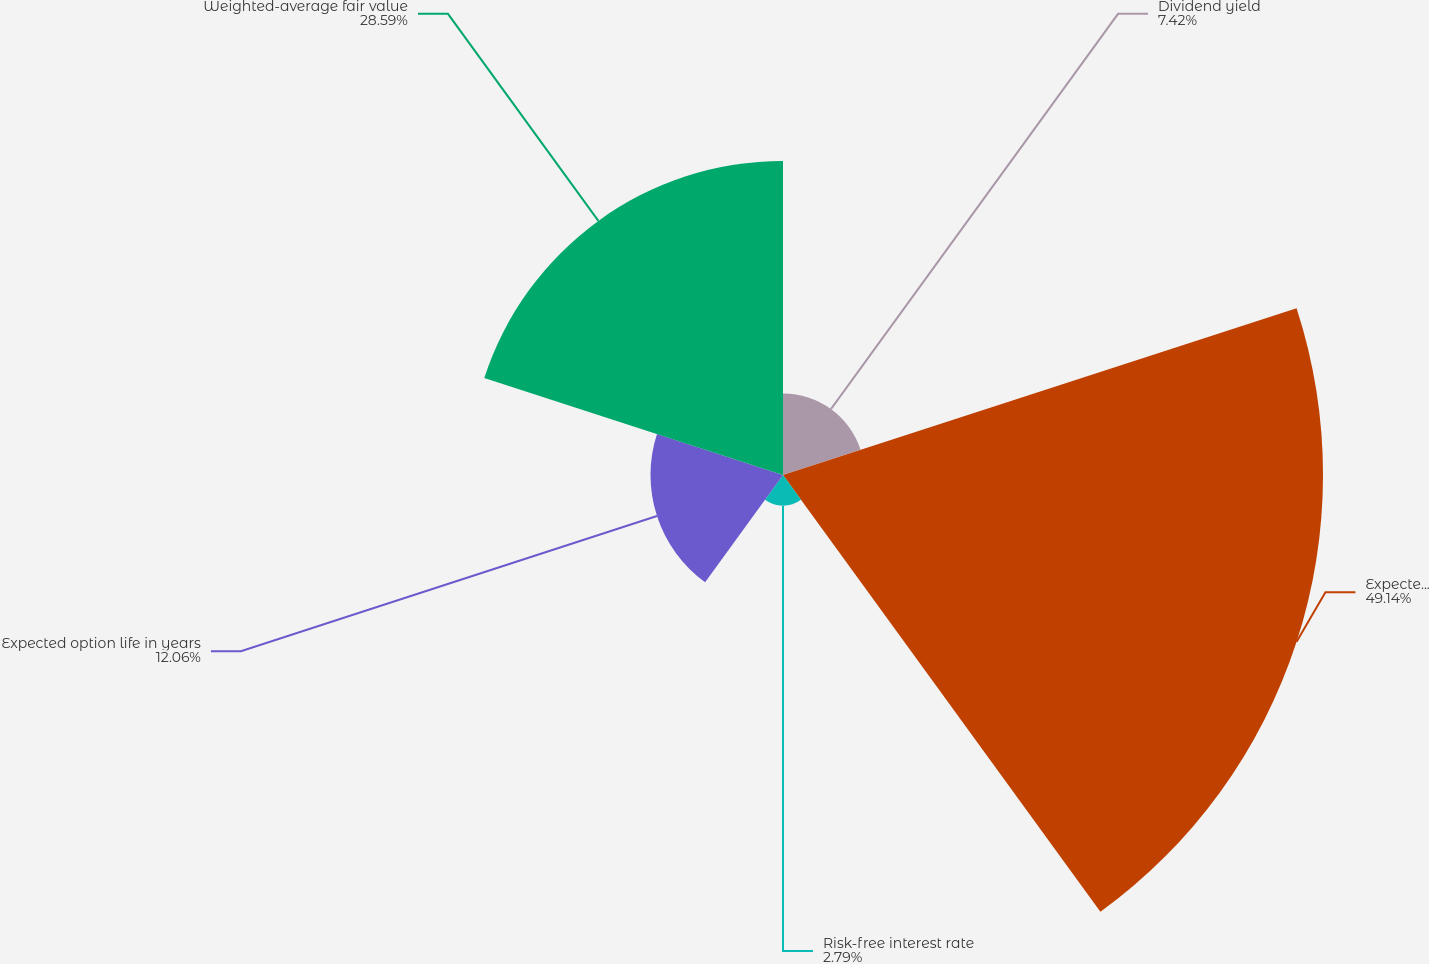Convert chart. <chart><loc_0><loc_0><loc_500><loc_500><pie_chart><fcel>Dividend yield<fcel>Expected volatility<fcel>Risk-free interest rate<fcel>Expected option life in years<fcel>Weighted-average fair value<nl><fcel>7.42%<fcel>49.15%<fcel>2.79%<fcel>12.06%<fcel>28.59%<nl></chart> 